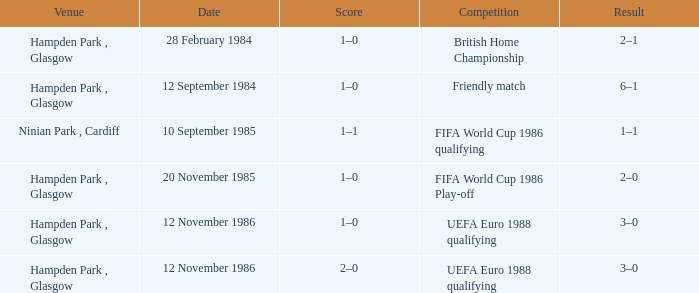What is the Date of the Competition with a Result of 3–0? 12 November 1986, 12 November 1986. 